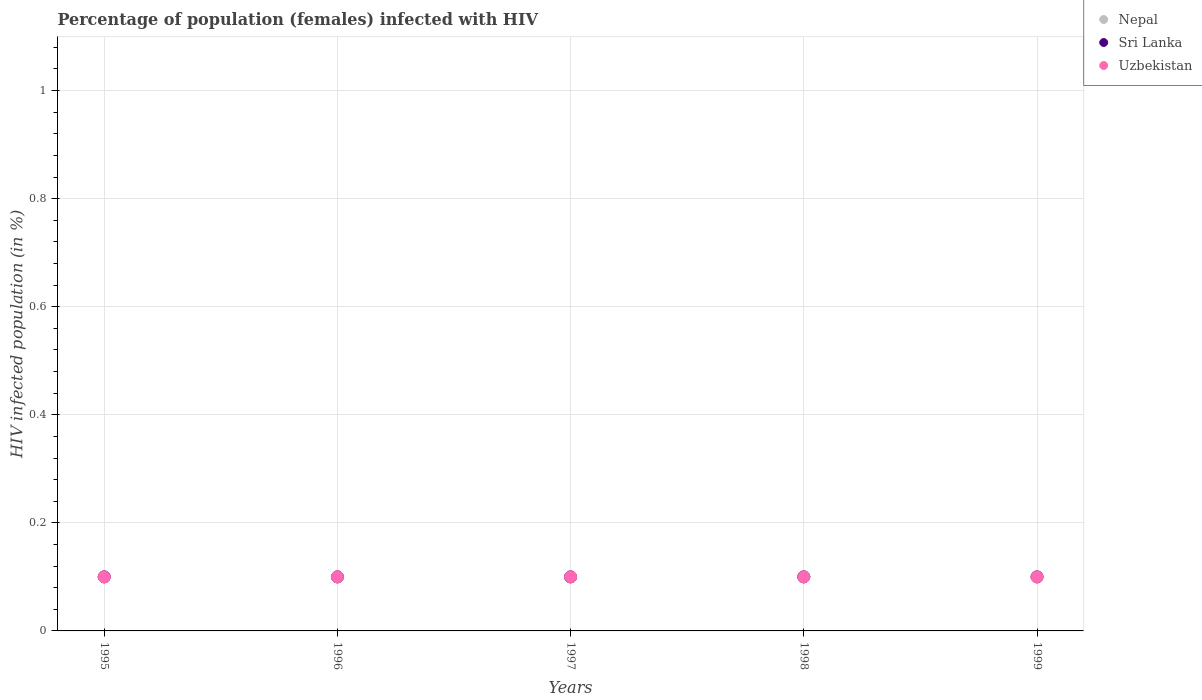How many different coloured dotlines are there?
Provide a succinct answer. 3. Is the number of dotlines equal to the number of legend labels?
Your response must be concise. Yes. Across all years, what is the minimum percentage of HIV infected female population in Sri Lanka?
Keep it short and to the point. 0.1. In which year was the percentage of HIV infected female population in Uzbekistan maximum?
Keep it short and to the point. 1995. What is the difference between the percentage of HIV infected female population in Sri Lanka in 1996 and that in 1997?
Ensure brevity in your answer.  0. What is the average percentage of HIV infected female population in Sri Lanka per year?
Your response must be concise. 0.1. In the year 1996, what is the difference between the percentage of HIV infected female population in Sri Lanka and percentage of HIV infected female population in Nepal?
Provide a short and direct response. 0. What is the ratio of the percentage of HIV infected female population in Nepal in 1995 to that in 1998?
Your response must be concise. 1. Is the percentage of HIV infected female population in Uzbekistan in 1995 less than that in 1999?
Make the answer very short. No. Is the difference between the percentage of HIV infected female population in Sri Lanka in 1995 and 1997 greater than the difference between the percentage of HIV infected female population in Nepal in 1995 and 1997?
Your response must be concise. No. Is the sum of the percentage of HIV infected female population in Nepal in 1997 and 1998 greater than the maximum percentage of HIV infected female population in Uzbekistan across all years?
Your answer should be compact. Yes. Is the percentage of HIV infected female population in Uzbekistan strictly greater than the percentage of HIV infected female population in Sri Lanka over the years?
Offer a very short reply. No. Is the percentage of HIV infected female population in Uzbekistan strictly less than the percentage of HIV infected female population in Sri Lanka over the years?
Make the answer very short. No. How many dotlines are there?
Your answer should be very brief. 3. Does the graph contain grids?
Ensure brevity in your answer.  Yes. Where does the legend appear in the graph?
Make the answer very short. Top right. How are the legend labels stacked?
Your answer should be compact. Vertical. What is the title of the graph?
Your answer should be compact. Percentage of population (females) infected with HIV. What is the label or title of the X-axis?
Make the answer very short. Years. What is the label or title of the Y-axis?
Make the answer very short. HIV infected population (in %). What is the HIV infected population (in %) of Sri Lanka in 1996?
Keep it short and to the point. 0.1. What is the HIV infected population (in %) in Nepal in 1997?
Provide a short and direct response. 0.1. What is the HIV infected population (in %) in Uzbekistan in 1997?
Give a very brief answer. 0.1. What is the HIV infected population (in %) in Nepal in 1998?
Make the answer very short. 0.1. What is the HIV infected population (in %) in Sri Lanka in 1998?
Make the answer very short. 0.1. What is the HIV infected population (in %) in Uzbekistan in 1998?
Provide a short and direct response. 0.1. What is the HIV infected population (in %) of Nepal in 1999?
Your answer should be very brief. 0.1. What is the HIV infected population (in %) of Sri Lanka in 1999?
Ensure brevity in your answer.  0.1. Across all years, what is the maximum HIV infected population (in %) in Uzbekistan?
Offer a terse response. 0.1. Across all years, what is the minimum HIV infected population (in %) in Nepal?
Keep it short and to the point. 0.1. Across all years, what is the minimum HIV infected population (in %) in Sri Lanka?
Keep it short and to the point. 0.1. What is the total HIV infected population (in %) of Nepal in the graph?
Give a very brief answer. 0.5. What is the difference between the HIV infected population (in %) of Uzbekistan in 1995 and that in 1997?
Your response must be concise. 0. What is the difference between the HIV infected population (in %) in Nepal in 1995 and that in 1998?
Give a very brief answer. 0. What is the difference between the HIV infected population (in %) in Sri Lanka in 1995 and that in 1999?
Provide a short and direct response. 0. What is the difference between the HIV infected population (in %) of Uzbekistan in 1995 and that in 1999?
Offer a very short reply. 0. What is the difference between the HIV infected population (in %) in Nepal in 1996 and that in 1997?
Ensure brevity in your answer.  0. What is the difference between the HIV infected population (in %) of Nepal in 1996 and that in 1998?
Provide a short and direct response. 0. What is the difference between the HIV infected population (in %) in Uzbekistan in 1996 and that in 1998?
Provide a short and direct response. 0. What is the difference between the HIV infected population (in %) in Nepal in 1996 and that in 1999?
Offer a very short reply. 0. What is the difference between the HIV infected population (in %) in Sri Lanka in 1997 and that in 1998?
Make the answer very short. 0. What is the difference between the HIV infected population (in %) of Nepal in 1997 and that in 1999?
Your response must be concise. 0. What is the difference between the HIV infected population (in %) of Sri Lanka in 1997 and that in 1999?
Offer a very short reply. 0. What is the difference between the HIV infected population (in %) in Nepal in 1998 and that in 1999?
Ensure brevity in your answer.  0. What is the difference between the HIV infected population (in %) in Nepal in 1995 and the HIV infected population (in %) in Sri Lanka in 1996?
Your response must be concise. 0. What is the difference between the HIV infected population (in %) in Nepal in 1995 and the HIV infected population (in %) in Uzbekistan in 1996?
Keep it short and to the point. 0. What is the difference between the HIV infected population (in %) in Sri Lanka in 1995 and the HIV infected population (in %) in Uzbekistan in 1997?
Provide a succinct answer. 0. What is the difference between the HIV infected population (in %) of Nepal in 1995 and the HIV infected population (in %) of Sri Lanka in 1998?
Provide a succinct answer. 0. What is the difference between the HIV infected population (in %) of Sri Lanka in 1995 and the HIV infected population (in %) of Uzbekistan in 1999?
Offer a terse response. 0. What is the difference between the HIV infected population (in %) of Nepal in 1996 and the HIV infected population (in %) of Sri Lanka in 1998?
Ensure brevity in your answer.  0. What is the difference between the HIV infected population (in %) of Nepal in 1996 and the HIV infected population (in %) of Sri Lanka in 1999?
Provide a short and direct response. 0. What is the difference between the HIV infected population (in %) of Sri Lanka in 1997 and the HIV infected population (in %) of Uzbekistan in 1999?
Your answer should be very brief. 0. What is the difference between the HIV infected population (in %) of Nepal in 1998 and the HIV infected population (in %) of Uzbekistan in 1999?
Provide a succinct answer. 0. What is the average HIV infected population (in %) of Sri Lanka per year?
Give a very brief answer. 0.1. In the year 1995, what is the difference between the HIV infected population (in %) of Nepal and HIV infected population (in %) of Sri Lanka?
Offer a terse response. 0. In the year 1995, what is the difference between the HIV infected population (in %) of Sri Lanka and HIV infected population (in %) of Uzbekistan?
Keep it short and to the point. 0. In the year 1996, what is the difference between the HIV infected population (in %) of Nepal and HIV infected population (in %) of Uzbekistan?
Offer a very short reply. 0. In the year 1997, what is the difference between the HIV infected population (in %) in Nepal and HIV infected population (in %) in Sri Lanka?
Give a very brief answer. 0. In the year 1997, what is the difference between the HIV infected population (in %) of Sri Lanka and HIV infected population (in %) of Uzbekistan?
Your answer should be compact. 0. What is the ratio of the HIV infected population (in %) of Sri Lanka in 1995 to that in 1996?
Provide a succinct answer. 1. What is the ratio of the HIV infected population (in %) of Uzbekistan in 1995 to that in 1996?
Provide a succinct answer. 1. What is the ratio of the HIV infected population (in %) of Sri Lanka in 1995 to that in 1997?
Keep it short and to the point. 1. What is the ratio of the HIV infected population (in %) in Uzbekistan in 1995 to that in 1997?
Keep it short and to the point. 1. What is the ratio of the HIV infected population (in %) in Nepal in 1995 to that in 1998?
Make the answer very short. 1. What is the ratio of the HIV infected population (in %) in Sri Lanka in 1995 to that in 1998?
Ensure brevity in your answer.  1. What is the ratio of the HIV infected population (in %) of Sri Lanka in 1995 to that in 1999?
Your answer should be compact. 1. What is the ratio of the HIV infected population (in %) in Uzbekistan in 1995 to that in 1999?
Offer a very short reply. 1. What is the ratio of the HIV infected population (in %) in Nepal in 1996 to that in 1997?
Give a very brief answer. 1. What is the ratio of the HIV infected population (in %) of Uzbekistan in 1996 to that in 1997?
Provide a succinct answer. 1. What is the ratio of the HIV infected population (in %) in Nepal in 1996 to that in 1998?
Your answer should be very brief. 1. What is the ratio of the HIV infected population (in %) in Nepal in 1996 to that in 1999?
Your response must be concise. 1. What is the ratio of the HIV infected population (in %) in Nepal in 1997 to that in 1998?
Ensure brevity in your answer.  1. What is the ratio of the HIV infected population (in %) in Sri Lanka in 1997 to that in 1998?
Your answer should be compact. 1. What is the ratio of the HIV infected population (in %) of Sri Lanka in 1997 to that in 1999?
Ensure brevity in your answer.  1. What is the ratio of the HIV infected population (in %) in Nepal in 1998 to that in 1999?
Your response must be concise. 1. What is the ratio of the HIV infected population (in %) of Sri Lanka in 1998 to that in 1999?
Give a very brief answer. 1. What is the ratio of the HIV infected population (in %) in Uzbekistan in 1998 to that in 1999?
Make the answer very short. 1. What is the difference between the highest and the lowest HIV infected population (in %) in Nepal?
Offer a very short reply. 0. 